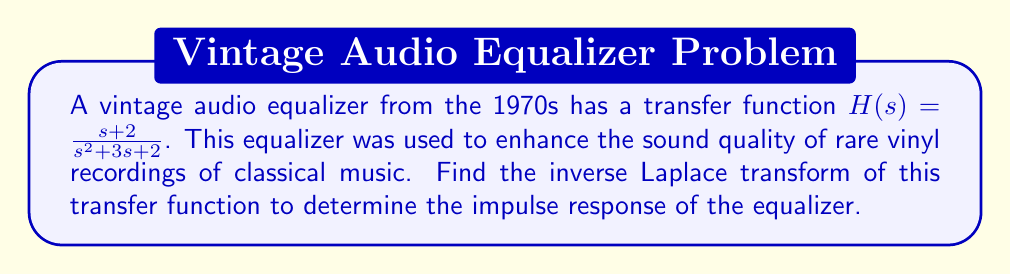What is the answer to this math problem? To find the inverse Laplace transform of the given transfer function, we'll follow these steps:

1) First, we need to decompose the transfer function into partial fractions:

   $$H(s) = \frac{s + 2}{s^2 + 3s + 2} = \frac{s + 2}{(s + 1)(s + 2)} = \frac{A}{s + 1} + \frac{B}{s + 2}$$

2) To find A and B, we'll solve the system of equations:

   $$s + 2 = A(s + 2) + B(s + 1)$$

   Letting $s = -1$: $1 = B$
   Letting $s = -2$: $0 = -A$

   Therefore, $A = 0$ and $B = 1$

3) Now we can rewrite our transfer function as:

   $$H(s) = \frac{1}{s + 2}$$

4) We can now use the Laplace transform table to find the inverse. The inverse Laplace transform of $\frac{1}{s + a}$ is $e^{-at}$.

5) Therefore, the inverse Laplace transform of $H(s)$ is:

   $$h(t) = e^{-2t}u(t)$$

   where $u(t)$ is the unit step function.

This impulse response shows how the equalizer responds to an impulse input, which is crucial for understanding how it modifies the sound of vintage recordings.
Answer: $h(t) = e^{-2t}u(t)$ 